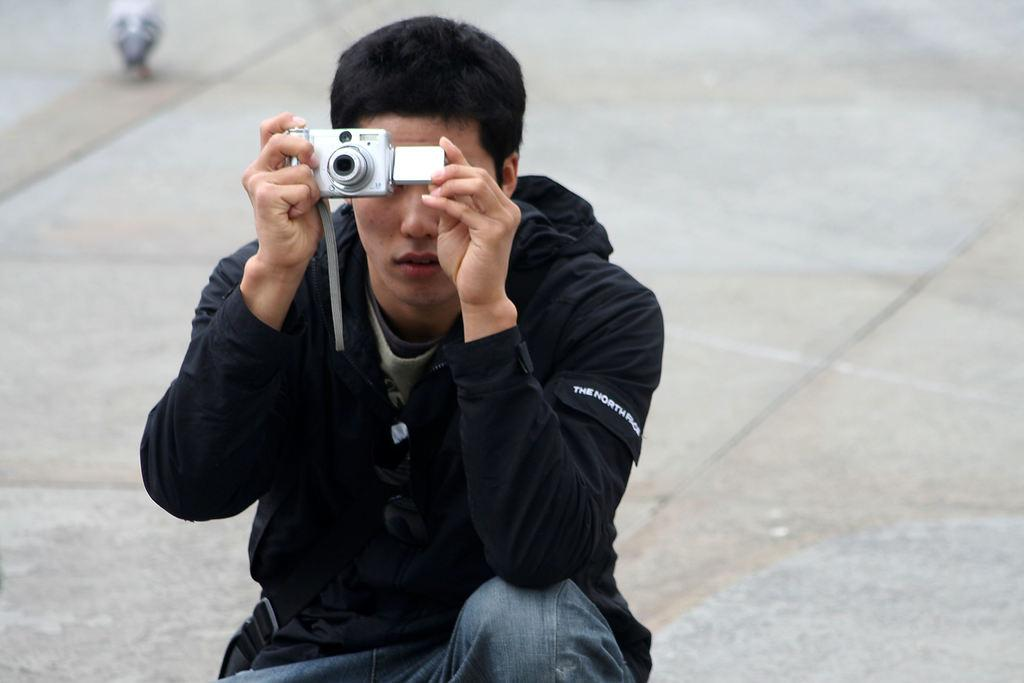What is the person in the image doing? The person is sitting and holding a camera in the image. What might the person be capturing with the camera? The person is capturing something, possibly the bird in the background of the image. What is the surface the person is sitting on? There is a floor visible in the image, which the person is likely sitting on. What type of thread is being used to create the show in the image? There is no show or thread present in the image; it features a person sitting and holding a camera. 